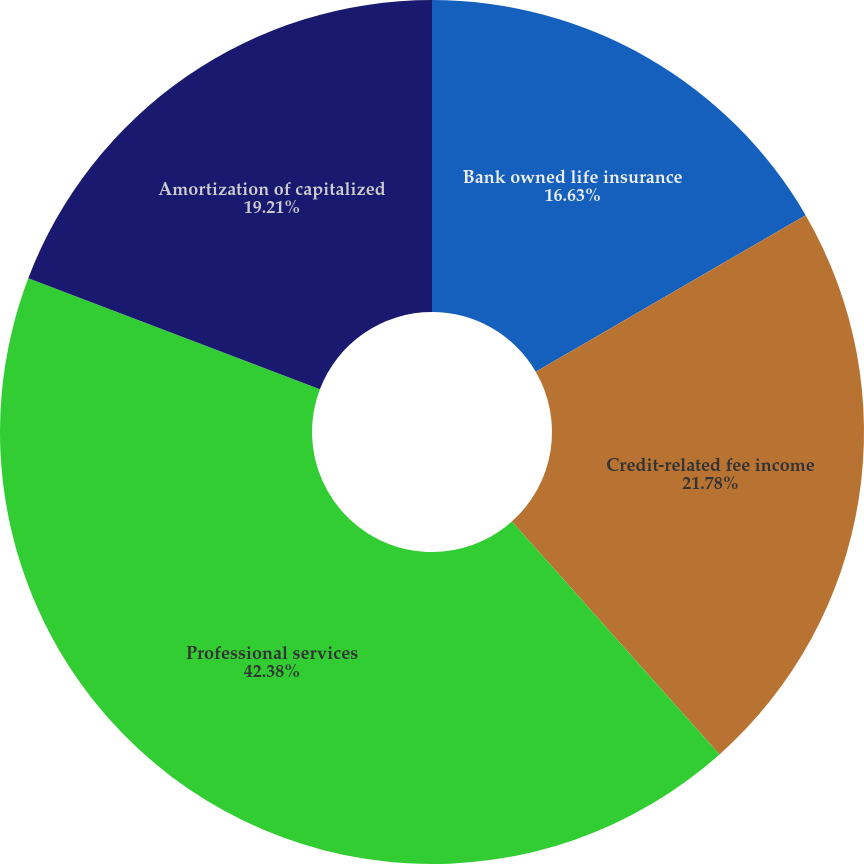Convert chart. <chart><loc_0><loc_0><loc_500><loc_500><pie_chart><fcel>Bank owned life insurance<fcel>Credit-related fee income<fcel>Professional services<fcel>Amortization of capitalized<nl><fcel>16.63%<fcel>21.78%<fcel>42.38%<fcel>19.21%<nl></chart> 